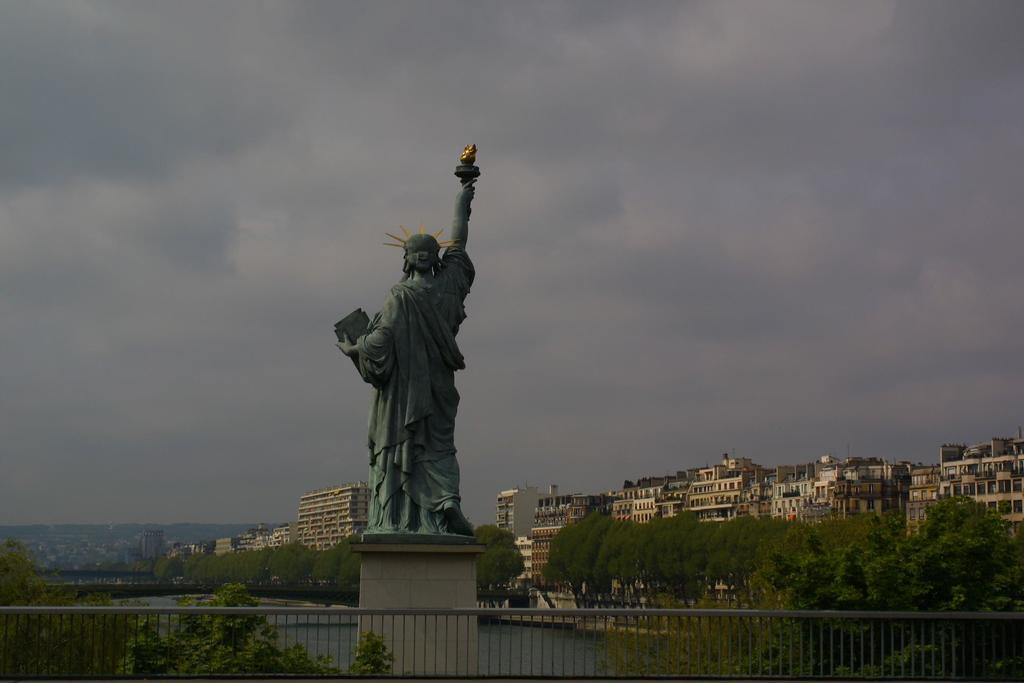What is the main subject in the image? There is a statue in the image. What can be seen surrounding the statue? There is a fence in the image. What type of natural elements are present in the image? There are trees in the image. What can be seen in the distance in the image? There is water, buildings, and clouds visible in the background of the image. What type of shoe is the statue wearing in the image? The statue does not have a shoe, as it is a statue and not a person. 